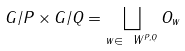Convert formula to latex. <formula><loc_0><loc_0><loc_500><loc_500>G / P \times G / Q = \bigsqcup _ { w \in \ W ^ { P , Q } } O _ { w }</formula> 